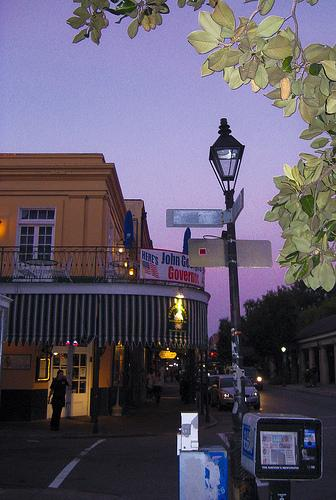Identify a specific object and briefly describe its appearance. A blue metal newspaper stand has a rectangular shape and is positioned near other similar objects on the street corner. In a casual tone, describe the restaurant entrance and its decor. The restaurant entrance has a cute white door with lights, and it's under this cool black and white striped awning. Comment on the presence of nature in this urban environment. In this urban scene, there is a tree with green leaves, which adds a hint of nature to the otherwise man-made surroundings. What action is the woman in the image taking? The woman is walking on the sidewalk. Using more formal language, describe the situation involving the lamppost and the newspaper stands. Within the image, a black metal street light is in proximity to numerous newspaper dispensers, which are placed on a corner of the street. Provide a concise description of the overall scene in the image. The image shows a city street with various objects like a lamppost, newspaper stands, parked cars, and a woman walking on the sidewalk near a building with a striped awning and a balcony. Enumerate three types of objects found in the image. Lamppost, newspaper stand, and parked car. How many newspaper machines are visible in the image? Provide the colors and brands of the machines as well. There are two main newspaper machines – a black and silver one and a blue metal one. The black and silver one is a USA Today newspaper machine. Create a short story using various objects and situations in the image. A woman walking down the street stops to buy a newspaper from a blue metal stand, glancing quickly at the governor campaign sign on the balcony above. As she walks away, she passes under a striped awning and decides to enter the restaurant with the white door for a scrumptious meal. Describe an object in the image that represents a political campaign. There is a running for governor sign displayed on a balcony. 